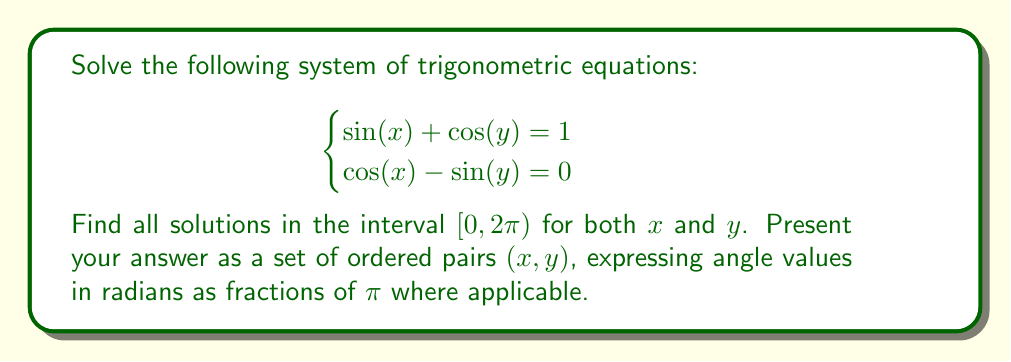Can you solve this math problem? Let's approach this step-by-step:

1) From the second equation: $\cos(x) = \sin(y)$

2) Square both sides of each equation:
   $$\begin{cases}
   \sin^2(x) + 2\sin(x)\cos(y) + \cos^2(y) = 1 \\
   \cos^2(x) = \sin^2(y)
   \end{cases}$$

3) Use the identity $\sin^2(θ) + \cos^2(θ) = 1$ to simplify:
   $$\begin{cases}
   1 - \cos^2(x) + 2\sin(x)\cos(y) + \cos^2(y) = 1 \\
   \cos^2(x) = 1 - \cos^2(y)
   \end{cases}$$

4) Substitute the second equation into the first:
   $$1 - (1 - \cos^2(y)) + 2\sin(x)\cos(y) + \cos^2(y) = 1$$

5) Simplify:
   $$2\cos^2(y) + 2\sin(x)\cos(y) = 1$$

6) Factor out $2\cos(y)$:
   $$2\cos(y)(\cos(y) + \sin(x)) = 1$$

7) From the original first equation: $\sin(x) + \cos(y) = 1$
   Substitute this into the factored equation:
   $$2\cos(y)(1) = 1$$

8) Solve for $\cos(y)$:
   $$\cos(y) = \frac{1}{2}$$

9) This means $y = \frac{\pi}{3}$ or $y = \frac{5\pi}{3}$ in $[0, 2\pi)$

10) Substitute back into $\sin(x) + \cos(y) = 1$:
    $$\sin(x) + \frac{1}{2} = 1$$
    $$\sin(x) = \frac{1}{2}$$

11) This means $x = \frac{\pi}{6}$ or $x = \frac{5\pi}{6}$ in $[0, 2\pi)$

12) Check which combinations satisfy the original system:
    - $(\frac{\pi}{6}, \frac{\pi}{3})$ satisfies both equations
    - $(\frac{5\pi}{6}, \frac{5\pi}{3})$ satisfies both equations

Therefore, the solution set consists of these two ordered pairs.
Answer: $\{(\frac{\pi}{6}, \frac{\pi}{3}), (\frac{5\pi}{6}, \frac{5\pi}{3})\}$ 